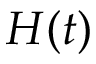<formula> <loc_0><loc_0><loc_500><loc_500>H ( t )</formula> 